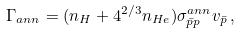Convert formula to latex. <formula><loc_0><loc_0><loc_500><loc_500>\Gamma _ { a n n } = ( n _ { H } + 4 ^ { 2 / 3 } n _ { H e } ) \sigma ^ { a n n } _ { \bar { p } p } v _ { \bar { p } } \, ,</formula> 